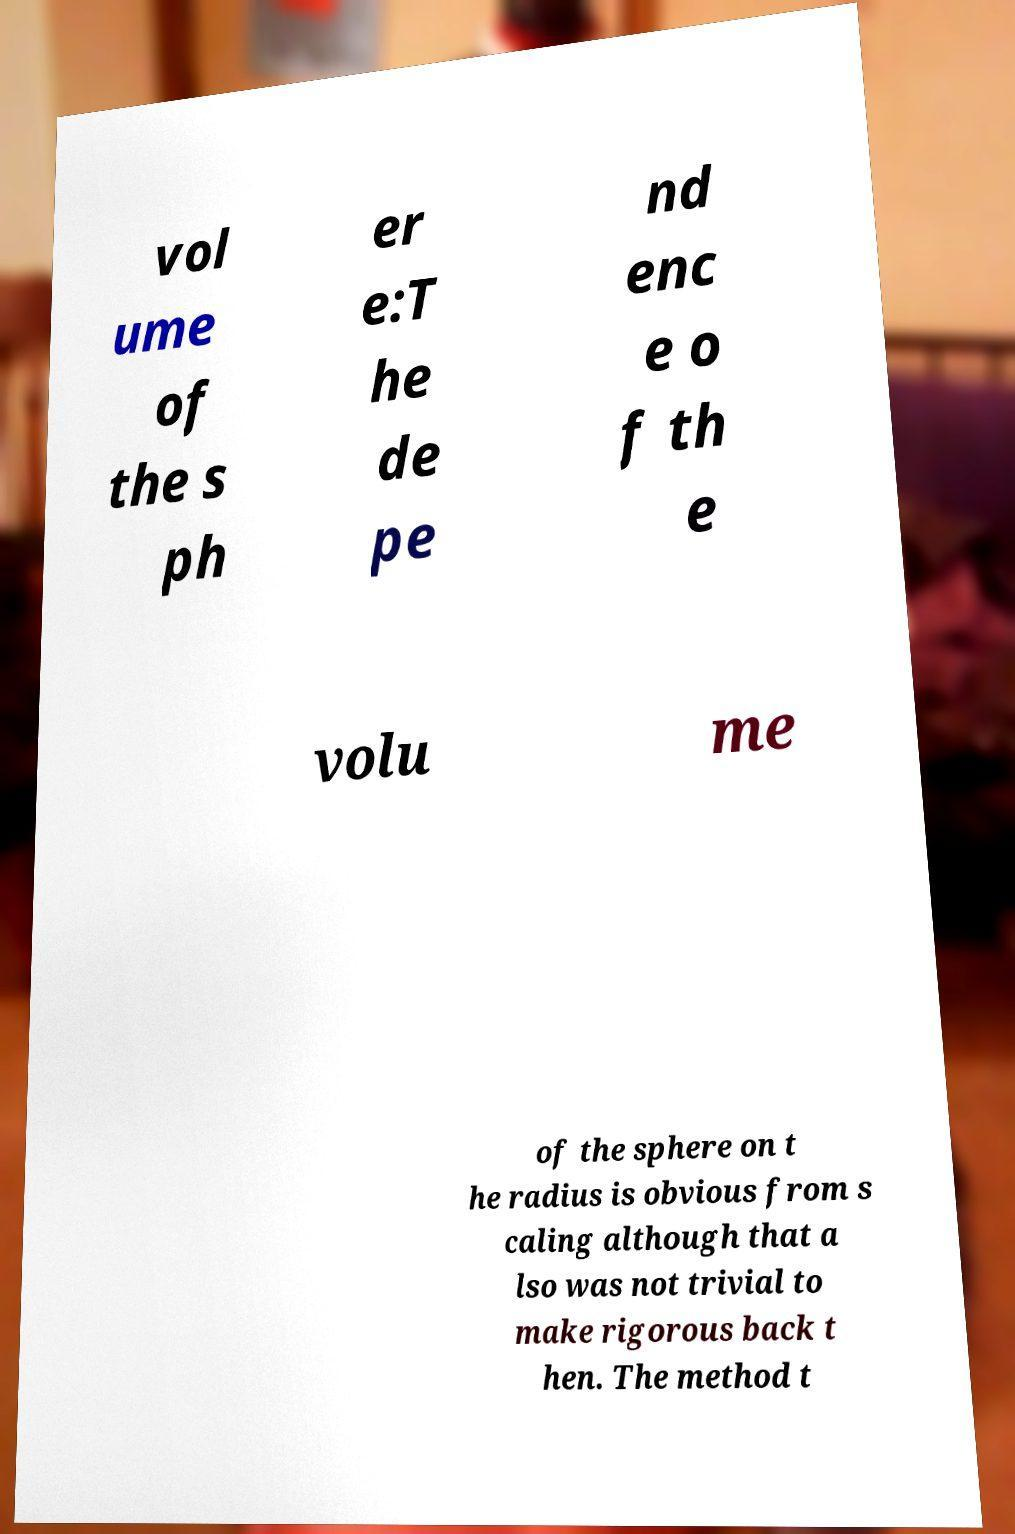Could you extract and type out the text from this image? vol ume of the s ph er e:T he de pe nd enc e o f th e volu me of the sphere on t he radius is obvious from s caling although that a lso was not trivial to make rigorous back t hen. The method t 